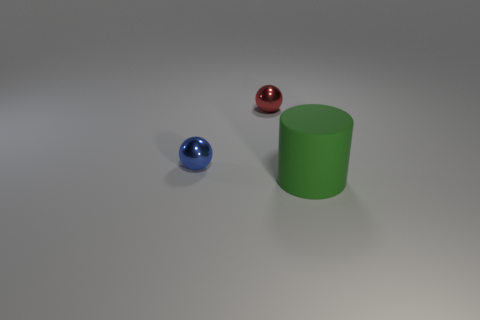There is a rubber thing; is its color the same as the shiny thing that is behind the blue object?
Provide a short and direct response. No. What is the color of the cylinder?
Provide a succinct answer. Green. What material is the sphere behind the small blue shiny thing?
Offer a very short reply. Metal. There is a blue metal object that is the same shape as the small red metal object; what size is it?
Ensure brevity in your answer.  Small. Are there fewer red objects that are on the left side of the blue metal ball than metal things?
Your answer should be very brief. Yes. Are there any big things?
Your answer should be compact. Yes. What is the color of the other tiny metal thing that is the same shape as the red object?
Your answer should be very brief. Blue. There is a tiny thing in front of the small red shiny thing; is it the same color as the large cylinder?
Ensure brevity in your answer.  No. Do the green thing and the red metallic ball have the same size?
Keep it short and to the point. No. There is a red thing that is the same material as the blue thing; what shape is it?
Ensure brevity in your answer.  Sphere. 